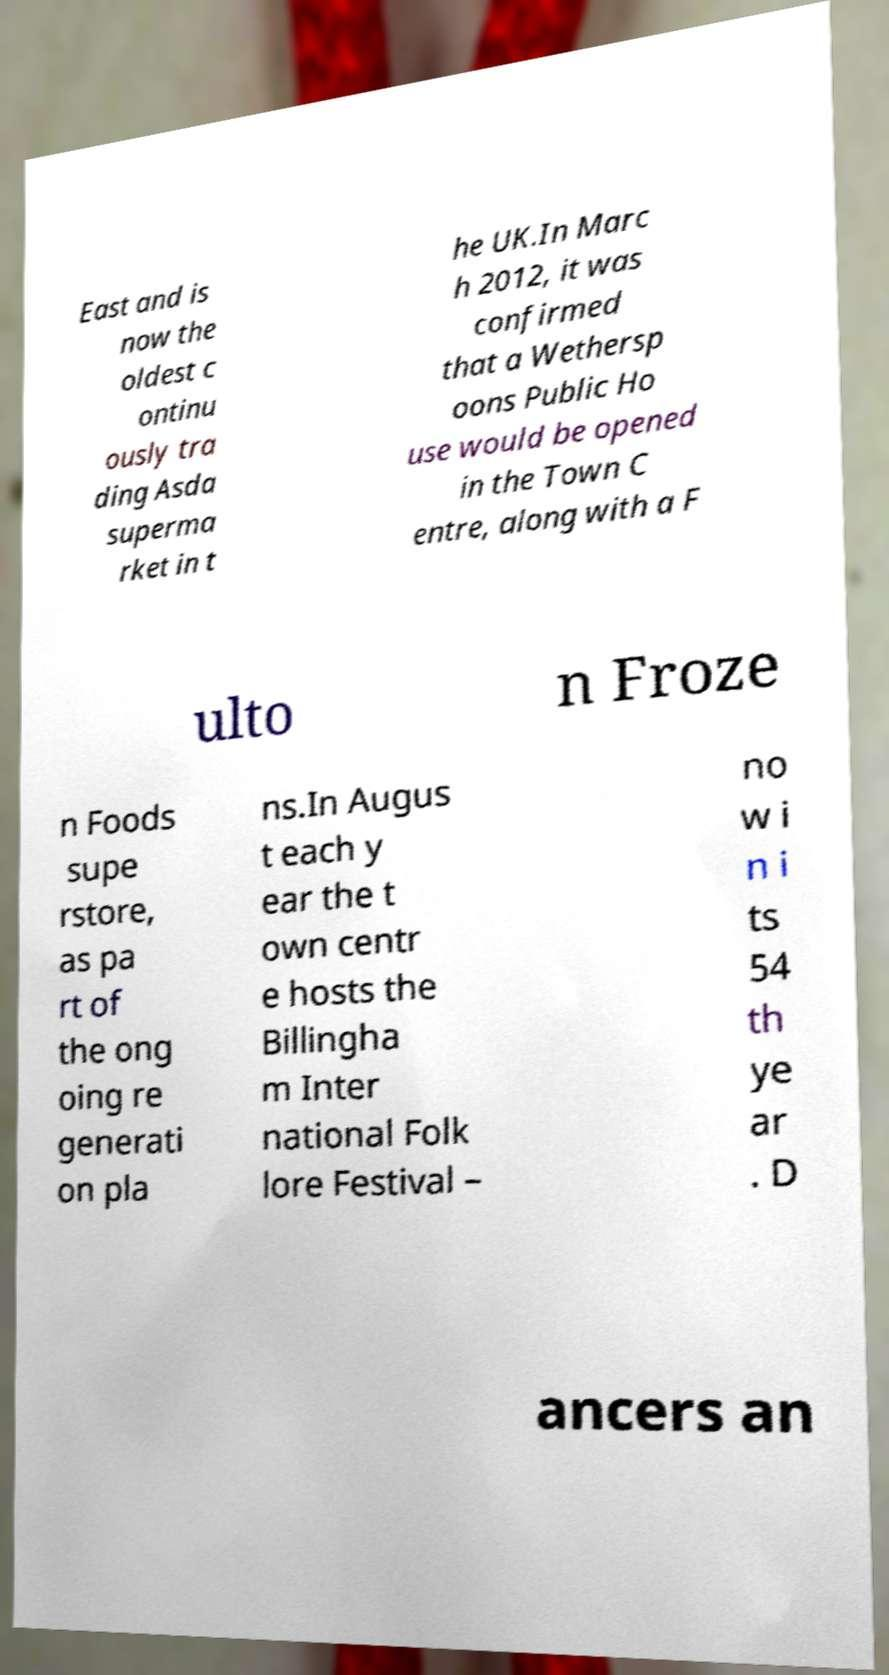What messages or text are displayed in this image? I need them in a readable, typed format. East and is now the oldest c ontinu ously tra ding Asda superma rket in t he UK.In Marc h 2012, it was confirmed that a Wethersp oons Public Ho use would be opened in the Town C entre, along with a F ulto n Froze n Foods supe rstore, as pa rt of the ong oing re generati on pla ns.In Augus t each y ear the t own centr e hosts the Billingha m Inter national Folk lore Festival – no w i n i ts 54 th ye ar . D ancers an 